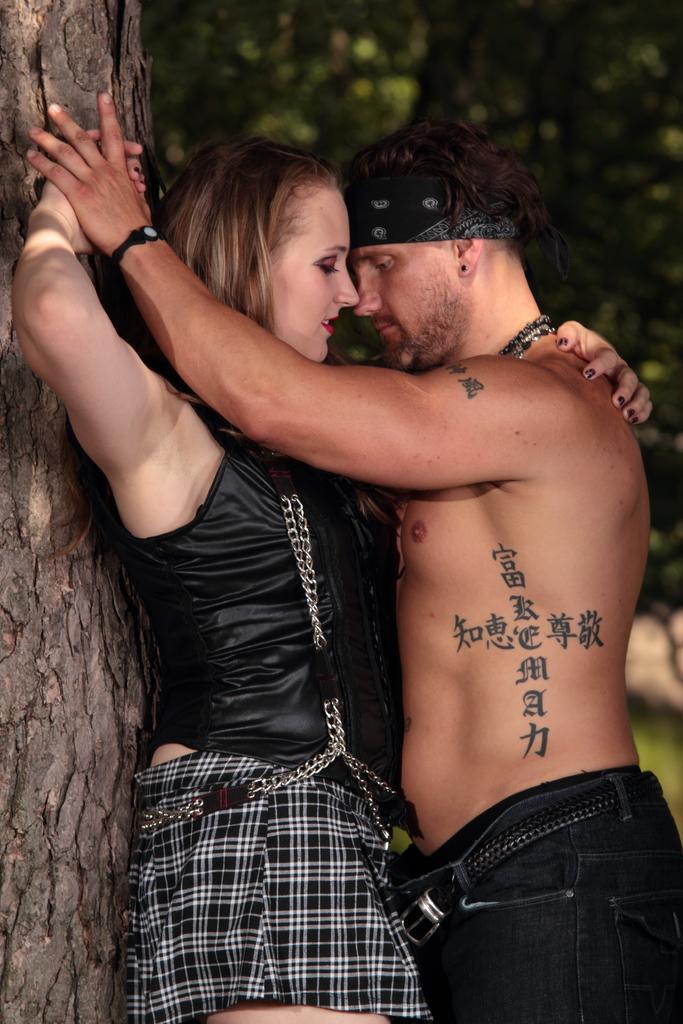How would you summarize this image in a sentence or two? In this image i can a couple doing romance beside the tree trunk, at the back there are so many trees. 